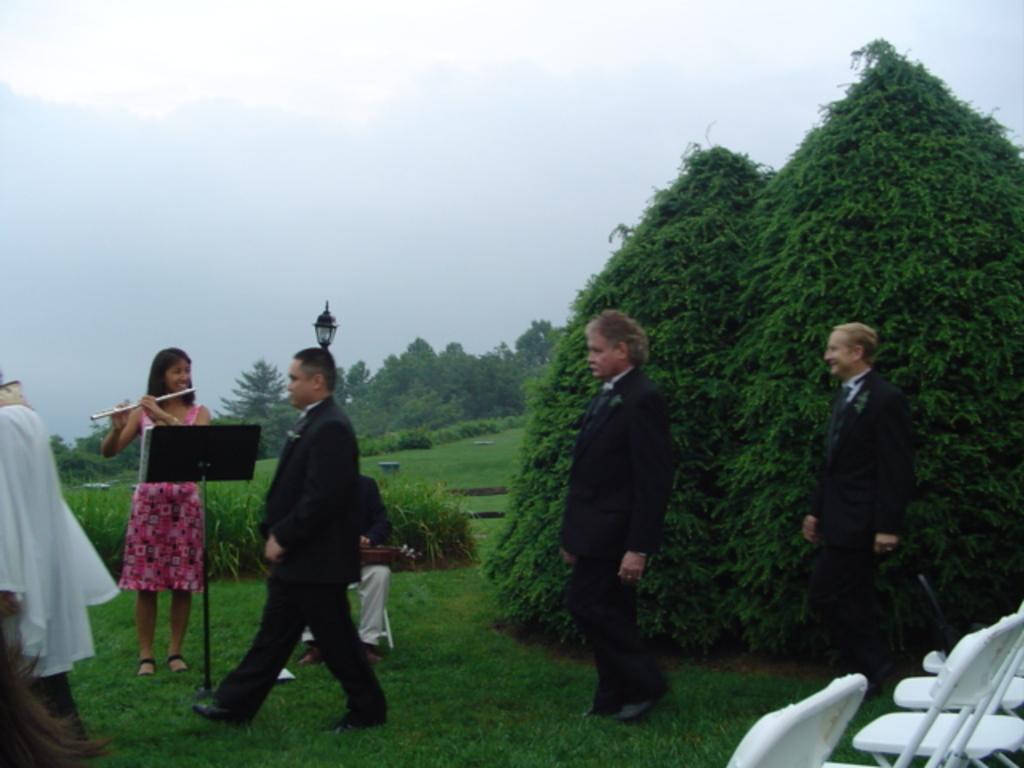How would you summarize this image in a sentence or two? As we can see in the image there are few people, plants, trees and chairs. There is grass, street lamp and at the top there is sky. The woman standing on the left side is wearing pink color dress and playing musical instrument. 